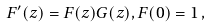Convert formula to latex. <formula><loc_0><loc_0><loc_500><loc_500>F ^ { \prime } ( z ) = F ( z ) G ( z ) , F ( 0 ) = 1 \, ,</formula> 